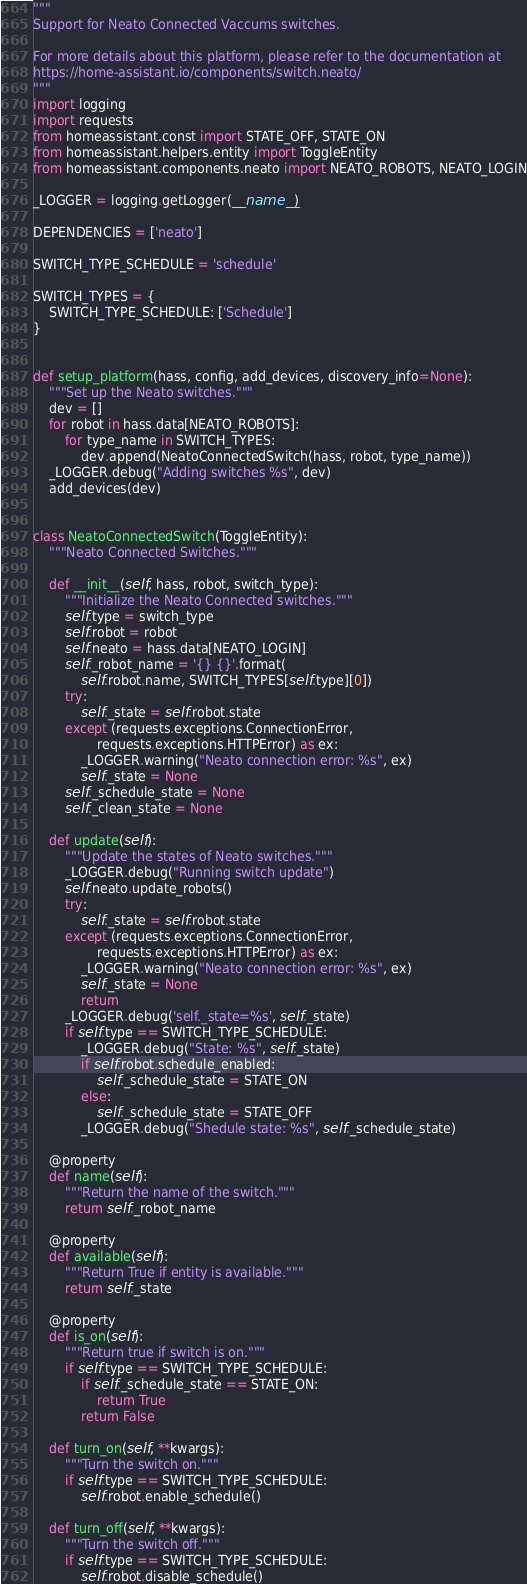<code> <loc_0><loc_0><loc_500><loc_500><_Python_>"""
Support for Neato Connected Vaccums switches.

For more details about this platform, please refer to the documentation at
https://home-assistant.io/components/switch.neato/
"""
import logging
import requests
from homeassistant.const import STATE_OFF, STATE_ON
from homeassistant.helpers.entity import ToggleEntity
from homeassistant.components.neato import NEATO_ROBOTS, NEATO_LOGIN

_LOGGER = logging.getLogger(__name__)

DEPENDENCIES = ['neato']

SWITCH_TYPE_SCHEDULE = 'schedule'

SWITCH_TYPES = {
    SWITCH_TYPE_SCHEDULE: ['Schedule']
}


def setup_platform(hass, config, add_devices, discovery_info=None):
    """Set up the Neato switches."""
    dev = []
    for robot in hass.data[NEATO_ROBOTS]:
        for type_name in SWITCH_TYPES:
            dev.append(NeatoConnectedSwitch(hass, robot, type_name))
    _LOGGER.debug("Adding switches %s", dev)
    add_devices(dev)


class NeatoConnectedSwitch(ToggleEntity):
    """Neato Connected Switches."""

    def __init__(self, hass, robot, switch_type):
        """Initialize the Neato Connected switches."""
        self.type = switch_type
        self.robot = robot
        self.neato = hass.data[NEATO_LOGIN]
        self._robot_name = '{} {}'.format(
            self.robot.name, SWITCH_TYPES[self.type][0])
        try:
            self._state = self.robot.state
        except (requests.exceptions.ConnectionError,
                requests.exceptions.HTTPError) as ex:
            _LOGGER.warning("Neato connection error: %s", ex)
            self._state = None
        self._schedule_state = None
        self._clean_state = None

    def update(self):
        """Update the states of Neato switches."""
        _LOGGER.debug("Running switch update")
        self.neato.update_robots()
        try:
            self._state = self.robot.state
        except (requests.exceptions.ConnectionError,
                requests.exceptions.HTTPError) as ex:
            _LOGGER.warning("Neato connection error: %s", ex)
            self._state = None
            return
        _LOGGER.debug('self._state=%s', self._state)
        if self.type == SWITCH_TYPE_SCHEDULE:
            _LOGGER.debug("State: %s", self._state)
            if self.robot.schedule_enabled:
                self._schedule_state = STATE_ON
            else:
                self._schedule_state = STATE_OFF
            _LOGGER.debug("Shedule state: %s", self._schedule_state)

    @property
    def name(self):
        """Return the name of the switch."""
        return self._robot_name

    @property
    def available(self):
        """Return True if entity is available."""
        return self._state

    @property
    def is_on(self):
        """Return true if switch is on."""
        if self.type == SWITCH_TYPE_SCHEDULE:
            if self._schedule_state == STATE_ON:
                return True
            return False

    def turn_on(self, **kwargs):
        """Turn the switch on."""
        if self.type == SWITCH_TYPE_SCHEDULE:
            self.robot.enable_schedule()

    def turn_off(self, **kwargs):
        """Turn the switch off."""
        if self.type == SWITCH_TYPE_SCHEDULE:
            self.robot.disable_schedule()
</code> 